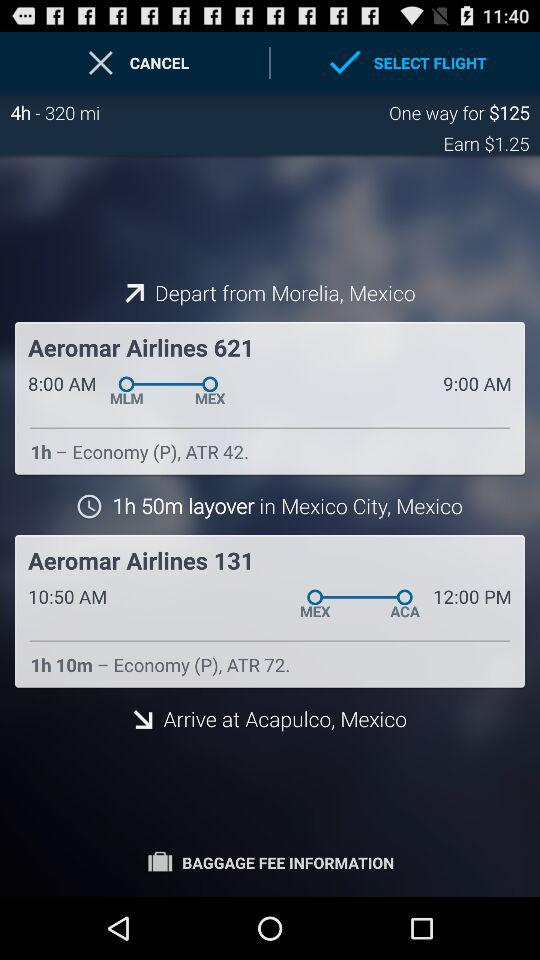How many hours is the layover in Mexico City?
Answer the question using a single word or phrase. 1h 50m 